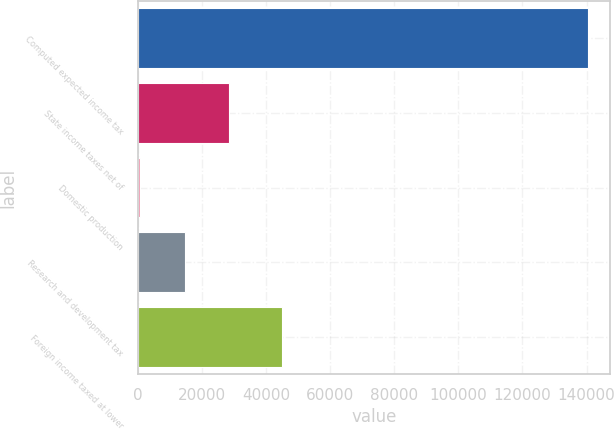Convert chart. <chart><loc_0><loc_0><loc_500><loc_500><bar_chart><fcel>Computed expected income tax<fcel>State income taxes net of<fcel>Domestic production<fcel>Research and development tax<fcel>Foreign income taxed at lower<nl><fcel>140382<fcel>28602.8<fcel>658<fcel>14630.4<fcel>44993<nl></chart> 